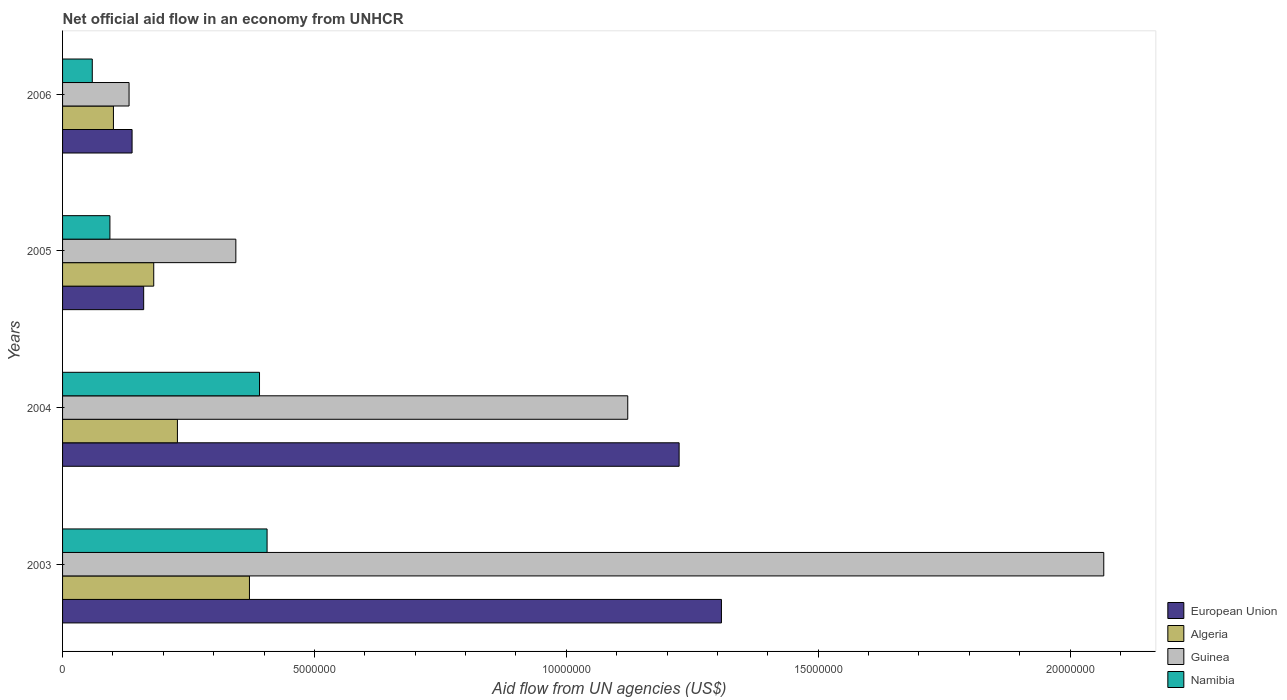How many different coloured bars are there?
Give a very brief answer. 4. How many bars are there on the 1st tick from the bottom?
Ensure brevity in your answer.  4. In how many cases, is the number of bars for a given year not equal to the number of legend labels?
Your response must be concise. 0. What is the net official aid flow in Namibia in 2005?
Give a very brief answer. 9.40e+05. Across all years, what is the maximum net official aid flow in European Union?
Make the answer very short. 1.31e+07. Across all years, what is the minimum net official aid flow in Namibia?
Make the answer very short. 5.90e+05. What is the total net official aid flow in Algeria in the graph?
Your answer should be compact. 8.81e+06. What is the difference between the net official aid flow in Guinea in 2005 and that in 2006?
Provide a succinct answer. 2.12e+06. What is the difference between the net official aid flow in Algeria in 2004 and the net official aid flow in Guinea in 2005?
Your answer should be very brief. -1.16e+06. What is the average net official aid flow in Guinea per year?
Make the answer very short. 9.16e+06. In the year 2006, what is the difference between the net official aid flow in Algeria and net official aid flow in Guinea?
Your answer should be compact. -3.10e+05. In how many years, is the net official aid flow in European Union greater than 16000000 US$?
Offer a very short reply. 0. What is the ratio of the net official aid flow in Algeria in 2004 to that in 2005?
Offer a very short reply. 1.26. What is the difference between the highest and the second highest net official aid flow in Namibia?
Give a very brief answer. 1.50e+05. What is the difference between the highest and the lowest net official aid flow in Namibia?
Keep it short and to the point. 3.47e+06. What does the 3rd bar from the top in 2004 represents?
Your answer should be very brief. Algeria. What does the 4th bar from the bottom in 2003 represents?
Your response must be concise. Namibia. Are all the bars in the graph horizontal?
Give a very brief answer. Yes. What is the difference between two consecutive major ticks on the X-axis?
Your answer should be compact. 5.00e+06. Are the values on the major ticks of X-axis written in scientific E-notation?
Your response must be concise. No. Does the graph contain any zero values?
Make the answer very short. No. What is the title of the graph?
Offer a terse response. Net official aid flow in an economy from UNHCR. Does "Hungary" appear as one of the legend labels in the graph?
Provide a succinct answer. No. What is the label or title of the X-axis?
Your answer should be compact. Aid flow from UN agencies (US$). What is the label or title of the Y-axis?
Your answer should be compact. Years. What is the Aid flow from UN agencies (US$) of European Union in 2003?
Your response must be concise. 1.31e+07. What is the Aid flow from UN agencies (US$) of Algeria in 2003?
Keep it short and to the point. 3.71e+06. What is the Aid flow from UN agencies (US$) of Guinea in 2003?
Your answer should be compact. 2.07e+07. What is the Aid flow from UN agencies (US$) in Namibia in 2003?
Your answer should be very brief. 4.06e+06. What is the Aid flow from UN agencies (US$) of European Union in 2004?
Offer a terse response. 1.22e+07. What is the Aid flow from UN agencies (US$) of Algeria in 2004?
Provide a short and direct response. 2.28e+06. What is the Aid flow from UN agencies (US$) in Guinea in 2004?
Provide a short and direct response. 1.12e+07. What is the Aid flow from UN agencies (US$) in Namibia in 2004?
Your answer should be compact. 3.91e+06. What is the Aid flow from UN agencies (US$) of European Union in 2005?
Ensure brevity in your answer.  1.61e+06. What is the Aid flow from UN agencies (US$) of Algeria in 2005?
Your answer should be compact. 1.81e+06. What is the Aid flow from UN agencies (US$) in Guinea in 2005?
Give a very brief answer. 3.44e+06. What is the Aid flow from UN agencies (US$) of Namibia in 2005?
Provide a short and direct response. 9.40e+05. What is the Aid flow from UN agencies (US$) of European Union in 2006?
Your answer should be compact. 1.38e+06. What is the Aid flow from UN agencies (US$) in Algeria in 2006?
Provide a succinct answer. 1.01e+06. What is the Aid flow from UN agencies (US$) in Guinea in 2006?
Keep it short and to the point. 1.32e+06. What is the Aid flow from UN agencies (US$) in Namibia in 2006?
Offer a very short reply. 5.90e+05. Across all years, what is the maximum Aid flow from UN agencies (US$) in European Union?
Ensure brevity in your answer.  1.31e+07. Across all years, what is the maximum Aid flow from UN agencies (US$) in Algeria?
Offer a very short reply. 3.71e+06. Across all years, what is the maximum Aid flow from UN agencies (US$) in Guinea?
Offer a very short reply. 2.07e+07. Across all years, what is the maximum Aid flow from UN agencies (US$) in Namibia?
Your answer should be compact. 4.06e+06. Across all years, what is the minimum Aid flow from UN agencies (US$) of European Union?
Provide a succinct answer. 1.38e+06. Across all years, what is the minimum Aid flow from UN agencies (US$) in Algeria?
Make the answer very short. 1.01e+06. Across all years, what is the minimum Aid flow from UN agencies (US$) in Guinea?
Your response must be concise. 1.32e+06. Across all years, what is the minimum Aid flow from UN agencies (US$) of Namibia?
Make the answer very short. 5.90e+05. What is the total Aid flow from UN agencies (US$) of European Union in the graph?
Keep it short and to the point. 2.83e+07. What is the total Aid flow from UN agencies (US$) in Algeria in the graph?
Ensure brevity in your answer.  8.81e+06. What is the total Aid flow from UN agencies (US$) of Guinea in the graph?
Make the answer very short. 3.66e+07. What is the total Aid flow from UN agencies (US$) in Namibia in the graph?
Give a very brief answer. 9.50e+06. What is the difference between the Aid flow from UN agencies (US$) of European Union in 2003 and that in 2004?
Keep it short and to the point. 8.40e+05. What is the difference between the Aid flow from UN agencies (US$) of Algeria in 2003 and that in 2004?
Make the answer very short. 1.43e+06. What is the difference between the Aid flow from UN agencies (US$) of Guinea in 2003 and that in 2004?
Give a very brief answer. 9.45e+06. What is the difference between the Aid flow from UN agencies (US$) in Namibia in 2003 and that in 2004?
Ensure brevity in your answer.  1.50e+05. What is the difference between the Aid flow from UN agencies (US$) in European Union in 2003 and that in 2005?
Ensure brevity in your answer.  1.15e+07. What is the difference between the Aid flow from UN agencies (US$) in Algeria in 2003 and that in 2005?
Offer a very short reply. 1.90e+06. What is the difference between the Aid flow from UN agencies (US$) of Guinea in 2003 and that in 2005?
Give a very brief answer. 1.72e+07. What is the difference between the Aid flow from UN agencies (US$) in Namibia in 2003 and that in 2005?
Keep it short and to the point. 3.12e+06. What is the difference between the Aid flow from UN agencies (US$) in European Union in 2003 and that in 2006?
Your answer should be compact. 1.17e+07. What is the difference between the Aid flow from UN agencies (US$) of Algeria in 2003 and that in 2006?
Make the answer very short. 2.70e+06. What is the difference between the Aid flow from UN agencies (US$) in Guinea in 2003 and that in 2006?
Keep it short and to the point. 1.94e+07. What is the difference between the Aid flow from UN agencies (US$) of Namibia in 2003 and that in 2006?
Your response must be concise. 3.47e+06. What is the difference between the Aid flow from UN agencies (US$) in European Union in 2004 and that in 2005?
Offer a very short reply. 1.06e+07. What is the difference between the Aid flow from UN agencies (US$) of Guinea in 2004 and that in 2005?
Ensure brevity in your answer.  7.78e+06. What is the difference between the Aid flow from UN agencies (US$) in Namibia in 2004 and that in 2005?
Your answer should be compact. 2.97e+06. What is the difference between the Aid flow from UN agencies (US$) in European Union in 2004 and that in 2006?
Your response must be concise. 1.09e+07. What is the difference between the Aid flow from UN agencies (US$) in Algeria in 2004 and that in 2006?
Keep it short and to the point. 1.27e+06. What is the difference between the Aid flow from UN agencies (US$) in Guinea in 2004 and that in 2006?
Your answer should be very brief. 9.90e+06. What is the difference between the Aid flow from UN agencies (US$) of Namibia in 2004 and that in 2006?
Provide a short and direct response. 3.32e+06. What is the difference between the Aid flow from UN agencies (US$) of European Union in 2005 and that in 2006?
Give a very brief answer. 2.30e+05. What is the difference between the Aid flow from UN agencies (US$) of Algeria in 2005 and that in 2006?
Give a very brief answer. 8.00e+05. What is the difference between the Aid flow from UN agencies (US$) of Guinea in 2005 and that in 2006?
Offer a terse response. 2.12e+06. What is the difference between the Aid flow from UN agencies (US$) in European Union in 2003 and the Aid flow from UN agencies (US$) in Algeria in 2004?
Give a very brief answer. 1.08e+07. What is the difference between the Aid flow from UN agencies (US$) of European Union in 2003 and the Aid flow from UN agencies (US$) of Guinea in 2004?
Provide a short and direct response. 1.86e+06. What is the difference between the Aid flow from UN agencies (US$) of European Union in 2003 and the Aid flow from UN agencies (US$) of Namibia in 2004?
Your response must be concise. 9.17e+06. What is the difference between the Aid flow from UN agencies (US$) in Algeria in 2003 and the Aid flow from UN agencies (US$) in Guinea in 2004?
Your response must be concise. -7.51e+06. What is the difference between the Aid flow from UN agencies (US$) of Guinea in 2003 and the Aid flow from UN agencies (US$) of Namibia in 2004?
Offer a terse response. 1.68e+07. What is the difference between the Aid flow from UN agencies (US$) of European Union in 2003 and the Aid flow from UN agencies (US$) of Algeria in 2005?
Your answer should be compact. 1.13e+07. What is the difference between the Aid flow from UN agencies (US$) in European Union in 2003 and the Aid flow from UN agencies (US$) in Guinea in 2005?
Provide a succinct answer. 9.64e+06. What is the difference between the Aid flow from UN agencies (US$) of European Union in 2003 and the Aid flow from UN agencies (US$) of Namibia in 2005?
Give a very brief answer. 1.21e+07. What is the difference between the Aid flow from UN agencies (US$) of Algeria in 2003 and the Aid flow from UN agencies (US$) of Guinea in 2005?
Provide a succinct answer. 2.70e+05. What is the difference between the Aid flow from UN agencies (US$) in Algeria in 2003 and the Aid flow from UN agencies (US$) in Namibia in 2005?
Offer a very short reply. 2.77e+06. What is the difference between the Aid flow from UN agencies (US$) in Guinea in 2003 and the Aid flow from UN agencies (US$) in Namibia in 2005?
Make the answer very short. 1.97e+07. What is the difference between the Aid flow from UN agencies (US$) in European Union in 2003 and the Aid flow from UN agencies (US$) in Algeria in 2006?
Your answer should be compact. 1.21e+07. What is the difference between the Aid flow from UN agencies (US$) in European Union in 2003 and the Aid flow from UN agencies (US$) in Guinea in 2006?
Offer a very short reply. 1.18e+07. What is the difference between the Aid flow from UN agencies (US$) in European Union in 2003 and the Aid flow from UN agencies (US$) in Namibia in 2006?
Give a very brief answer. 1.25e+07. What is the difference between the Aid flow from UN agencies (US$) in Algeria in 2003 and the Aid flow from UN agencies (US$) in Guinea in 2006?
Make the answer very short. 2.39e+06. What is the difference between the Aid flow from UN agencies (US$) in Algeria in 2003 and the Aid flow from UN agencies (US$) in Namibia in 2006?
Provide a succinct answer. 3.12e+06. What is the difference between the Aid flow from UN agencies (US$) in Guinea in 2003 and the Aid flow from UN agencies (US$) in Namibia in 2006?
Ensure brevity in your answer.  2.01e+07. What is the difference between the Aid flow from UN agencies (US$) in European Union in 2004 and the Aid flow from UN agencies (US$) in Algeria in 2005?
Your answer should be compact. 1.04e+07. What is the difference between the Aid flow from UN agencies (US$) of European Union in 2004 and the Aid flow from UN agencies (US$) of Guinea in 2005?
Your answer should be compact. 8.80e+06. What is the difference between the Aid flow from UN agencies (US$) of European Union in 2004 and the Aid flow from UN agencies (US$) of Namibia in 2005?
Make the answer very short. 1.13e+07. What is the difference between the Aid flow from UN agencies (US$) of Algeria in 2004 and the Aid flow from UN agencies (US$) of Guinea in 2005?
Keep it short and to the point. -1.16e+06. What is the difference between the Aid flow from UN agencies (US$) of Algeria in 2004 and the Aid flow from UN agencies (US$) of Namibia in 2005?
Provide a succinct answer. 1.34e+06. What is the difference between the Aid flow from UN agencies (US$) in Guinea in 2004 and the Aid flow from UN agencies (US$) in Namibia in 2005?
Keep it short and to the point. 1.03e+07. What is the difference between the Aid flow from UN agencies (US$) in European Union in 2004 and the Aid flow from UN agencies (US$) in Algeria in 2006?
Keep it short and to the point. 1.12e+07. What is the difference between the Aid flow from UN agencies (US$) in European Union in 2004 and the Aid flow from UN agencies (US$) in Guinea in 2006?
Provide a short and direct response. 1.09e+07. What is the difference between the Aid flow from UN agencies (US$) of European Union in 2004 and the Aid flow from UN agencies (US$) of Namibia in 2006?
Your answer should be compact. 1.16e+07. What is the difference between the Aid flow from UN agencies (US$) of Algeria in 2004 and the Aid flow from UN agencies (US$) of Guinea in 2006?
Offer a terse response. 9.60e+05. What is the difference between the Aid flow from UN agencies (US$) of Algeria in 2004 and the Aid flow from UN agencies (US$) of Namibia in 2006?
Your response must be concise. 1.69e+06. What is the difference between the Aid flow from UN agencies (US$) in Guinea in 2004 and the Aid flow from UN agencies (US$) in Namibia in 2006?
Make the answer very short. 1.06e+07. What is the difference between the Aid flow from UN agencies (US$) in European Union in 2005 and the Aid flow from UN agencies (US$) in Namibia in 2006?
Provide a succinct answer. 1.02e+06. What is the difference between the Aid flow from UN agencies (US$) in Algeria in 2005 and the Aid flow from UN agencies (US$) in Namibia in 2006?
Provide a succinct answer. 1.22e+06. What is the difference between the Aid flow from UN agencies (US$) of Guinea in 2005 and the Aid flow from UN agencies (US$) of Namibia in 2006?
Your answer should be very brief. 2.85e+06. What is the average Aid flow from UN agencies (US$) in European Union per year?
Provide a succinct answer. 7.08e+06. What is the average Aid flow from UN agencies (US$) of Algeria per year?
Make the answer very short. 2.20e+06. What is the average Aid flow from UN agencies (US$) of Guinea per year?
Give a very brief answer. 9.16e+06. What is the average Aid flow from UN agencies (US$) of Namibia per year?
Make the answer very short. 2.38e+06. In the year 2003, what is the difference between the Aid flow from UN agencies (US$) in European Union and Aid flow from UN agencies (US$) in Algeria?
Keep it short and to the point. 9.37e+06. In the year 2003, what is the difference between the Aid flow from UN agencies (US$) of European Union and Aid flow from UN agencies (US$) of Guinea?
Your answer should be compact. -7.59e+06. In the year 2003, what is the difference between the Aid flow from UN agencies (US$) of European Union and Aid flow from UN agencies (US$) of Namibia?
Give a very brief answer. 9.02e+06. In the year 2003, what is the difference between the Aid flow from UN agencies (US$) of Algeria and Aid flow from UN agencies (US$) of Guinea?
Provide a succinct answer. -1.70e+07. In the year 2003, what is the difference between the Aid flow from UN agencies (US$) of Algeria and Aid flow from UN agencies (US$) of Namibia?
Offer a very short reply. -3.50e+05. In the year 2003, what is the difference between the Aid flow from UN agencies (US$) in Guinea and Aid flow from UN agencies (US$) in Namibia?
Offer a very short reply. 1.66e+07. In the year 2004, what is the difference between the Aid flow from UN agencies (US$) in European Union and Aid flow from UN agencies (US$) in Algeria?
Offer a very short reply. 9.96e+06. In the year 2004, what is the difference between the Aid flow from UN agencies (US$) in European Union and Aid flow from UN agencies (US$) in Guinea?
Your answer should be compact. 1.02e+06. In the year 2004, what is the difference between the Aid flow from UN agencies (US$) in European Union and Aid flow from UN agencies (US$) in Namibia?
Provide a short and direct response. 8.33e+06. In the year 2004, what is the difference between the Aid flow from UN agencies (US$) in Algeria and Aid flow from UN agencies (US$) in Guinea?
Ensure brevity in your answer.  -8.94e+06. In the year 2004, what is the difference between the Aid flow from UN agencies (US$) in Algeria and Aid flow from UN agencies (US$) in Namibia?
Provide a short and direct response. -1.63e+06. In the year 2004, what is the difference between the Aid flow from UN agencies (US$) in Guinea and Aid flow from UN agencies (US$) in Namibia?
Give a very brief answer. 7.31e+06. In the year 2005, what is the difference between the Aid flow from UN agencies (US$) of European Union and Aid flow from UN agencies (US$) of Algeria?
Provide a short and direct response. -2.00e+05. In the year 2005, what is the difference between the Aid flow from UN agencies (US$) of European Union and Aid flow from UN agencies (US$) of Guinea?
Give a very brief answer. -1.83e+06. In the year 2005, what is the difference between the Aid flow from UN agencies (US$) of European Union and Aid flow from UN agencies (US$) of Namibia?
Ensure brevity in your answer.  6.70e+05. In the year 2005, what is the difference between the Aid flow from UN agencies (US$) of Algeria and Aid flow from UN agencies (US$) of Guinea?
Your response must be concise. -1.63e+06. In the year 2005, what is the difference between the Aid flow from UN agencies (US$) in Algeria and Aid flow from UN agencies (US$) in Namibia?
Ensure brevity in your answer.  8.70e+05. In the year 2005, what is the difference between the Aid flow from UN agencies (US$) of Guinea and Aid flow from UN agencies (US$) of Namibia?
Offer a very short reply. 2.50e+06. In the year 2006, what is the difference between the Aid flow from UN agencies (US$) in European Union and Aid flow from UN agencies (US$) in Algeria?
Your response must be concise. 3.70e+05. In the year 2006, what is the difference between the Aid flow from UN agencies (US$) of European Union and Aid flow from UN agencies (US$) of Guinea?
Provide a succinct answer. 6.00e+04. In the year 2006, what is the difference between the Aid flow from UN agencies (US$) in European Union and Aid flow from UN agencies (US$) in Namibia?
Give a very brief answer. 7.90e+05. In the year 2006, what is the difference between the Aid flow from UN agencies (US$) in Algeria and Aid flow from UN agencies (US$) in Guinea?
Provide a succinct answer. -3.10e+05. In the year 2006, what is the difference between the Aid flow from UN agencies (US$) of Algeria and Aid flow from UN agencies (US$) of Namibia?
Make the answer very short. 4.20e+05. In the year 2006, what is the difference between the Aid flow from UN agencies (US$) in Guinea and Aid flow from UN agencies (US$) in Namibia?
Offer a terse response. 7.30e+05. What is the ratio of the Aid flow from UN agencies (US$) in European Union in 2003 to that in 2004?
Offer a terse response. 1.07. What is the ratio of the Aid flow from UN agencies (US$) of Algeria in 2003 to that in 2004?
Give a very brief answer. 1.63. What is the ratio of the Aid flow from UN agencies (US$) in Guinea in 2003 to that in 2004?
Provide a short and direct response. 1.84. What is the ratio of the Aid flow from UN agencies (US$) of Namibia in 2003 to that in 2004?
Give a very brief answer. 1.04. What is the ratio of the Aid flow from UN agencies (US$) of European Union in 2003 to that in 2005?
Your answer should be compact. 8.12. What is the ratio of the Aid flow from UN agencies (US$) in Algeria in 2003 to that in 2005?
Ensure brevity in your answer.  2.05. What is the ratio of the Aid flow from UN agencies (US$) of Guinea in 2003 to that in 2005?
Offer a very short reply. 6.01. What is the ratio of the Aid flow from UN agencies (US$) in Namibia in 2003 to that in 2005?
Provide a succinct answer. 4.32. What is the ratio of the Aid flow from UN agencies (US$) in European Union in 2003 to that in 2006?
Your answer should be compact. 9.48. What is the ratio of the Aid flow from UN agencies (US$) in Algeria in 2003 to that in 2006?
Your response must be concise. 3.67. What is the ratio of the Aid flow from UN agencies (US$) in Guinea in 2003 to that in 2006?
Offer a terse response. 15.66. What is the ratio of the Aid flow from UN agencies (US$) of Namibia in 2003 to that in 2006?
Provide a short and direct response. 6.88. What is the ratio of the Aid flow from UN agencies (US$) of European Union in 2004 to that in 2005?
Offer a terse response. 7.6. What is the ratio of the Aid flow from UN agencies (US$) of Algeria in 2004 to that in 2005?
Make the answer very short. 1.26. What is the ratio of the Aid flow from UN agencies (US$) of Guinea in 2004 to that in 2005?
Offer a very short reply. 3.26. What is the ratio of the Aid flow from UN agencies (US$) in Namibia in 2004 to that in 2005?
Keep it short and to the point. 4.16. What is the ratio of the Aid flow from UN agencies (US$) in European Union in 2004 to that in 2006?
Your answer should be compact. 8.87. What is the ratio of the Aid flow from UN agencies (US$) in Algeria in 2004 to that in 2006?
Give a very brief answer. 2.26. What is the ratio of the Aid flow from UN agencies (US$) in Namibia in 2004 to that in 2006?
Give a very brief answer. 6.63. What is the ratio of the Aid flow from UN agencies (US$) in European Union in 2005 to that in 2006?
Make the answer very short. 1.17. What is the ratio of the Aid flow from UN agencies (US$) of Algeria in 2005 to that in 2006?
Offer a very short reply. 1.79. What is the ratio of the Aid flow from UN agencies (US$) in Guinea in 2005 to that in 2006?
Your answer should be compact. 2.61. What is the ratio of the Aid flow from UN agencies (US$) of Namibia in 2005 to that in 2006?
Keep it short and to the point. 1.59. What is the difference between the highest and the second highest Aid flow from UN agencies (US$) in European Union?
Keep it short and to the point. 8.40e+05. What is the difference between the highest and the second highest Aid flow from UN agencies (US$) in Algeria?
Give a very brief answer. 1.43e+06. What is the difference between the highest and the second highest Aid flow from UN agencies (US$) in Guinea?
Offer a terse response. 9.45e+06. What is the difference between the highest and the lowest Aid flow from UN agencies (US$) in European Union?
Provide a short and direct response. 1.17e+07. What is the difference between the highest and the lowest Aid flow from UN agencies (US$) of Algeria?
Your response must be concise. 2.70e+06. What is the difference between the highest and the lowest Aid flow from UN agencies (US$) in Guinea?
Offer a very short reply. 1.94e+07. What is the difference between the highest and the lowest Aid flow from UN agencies (US$) in Namibia?
Ensure brevity in your answer.  3.47e+06. 